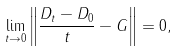<formula> <loc_0><loc_0><loc_500><loc_500>\lim _ { t \rightarrow 0 } \left \| \frac { D _ { t } - D _ { 0 } } t - G \right \| = 0 ,</formula> 